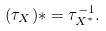<formula> <loc_0><loc_0><loc_500><loc_500>( \tau _ { X } ) \ast = \tau _ { X ^ { \ast } } ^ { - 1 } .</formula> 